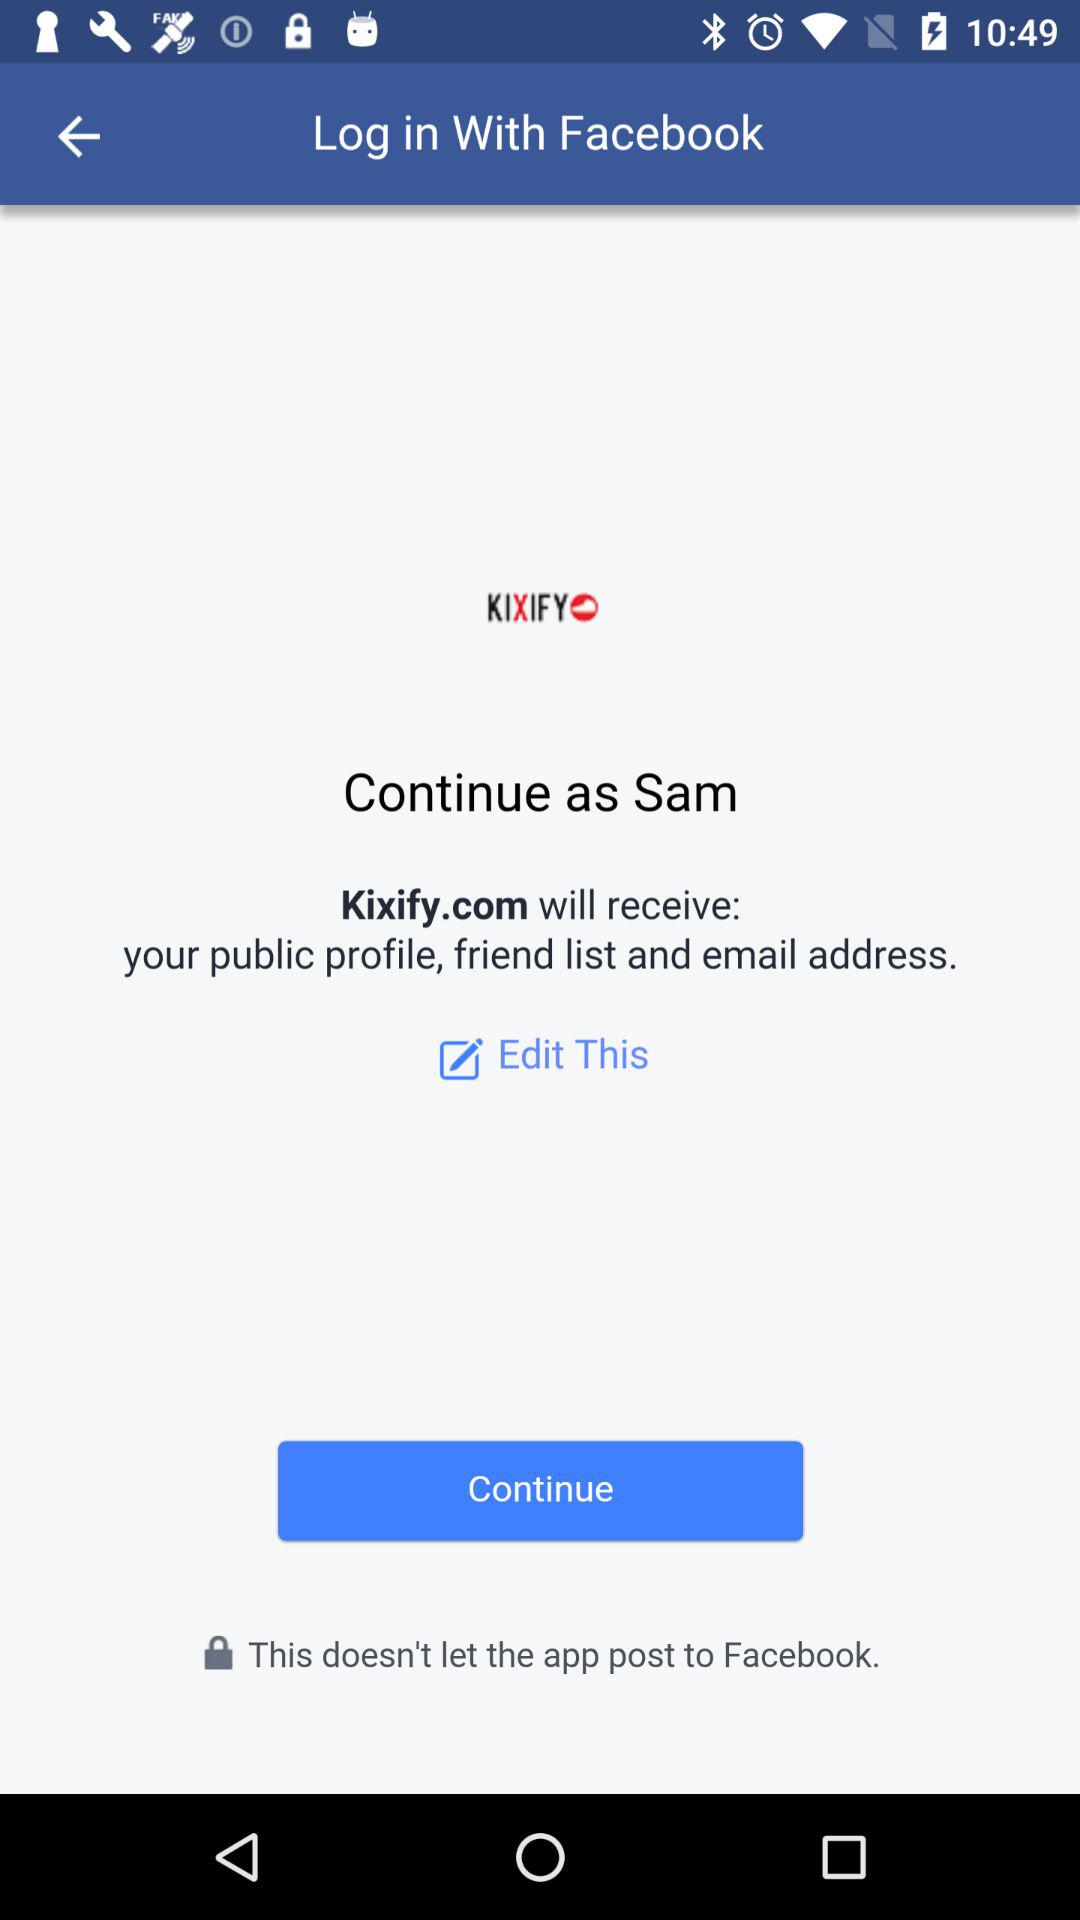What is the application name? The application name is "KIXIFY". 